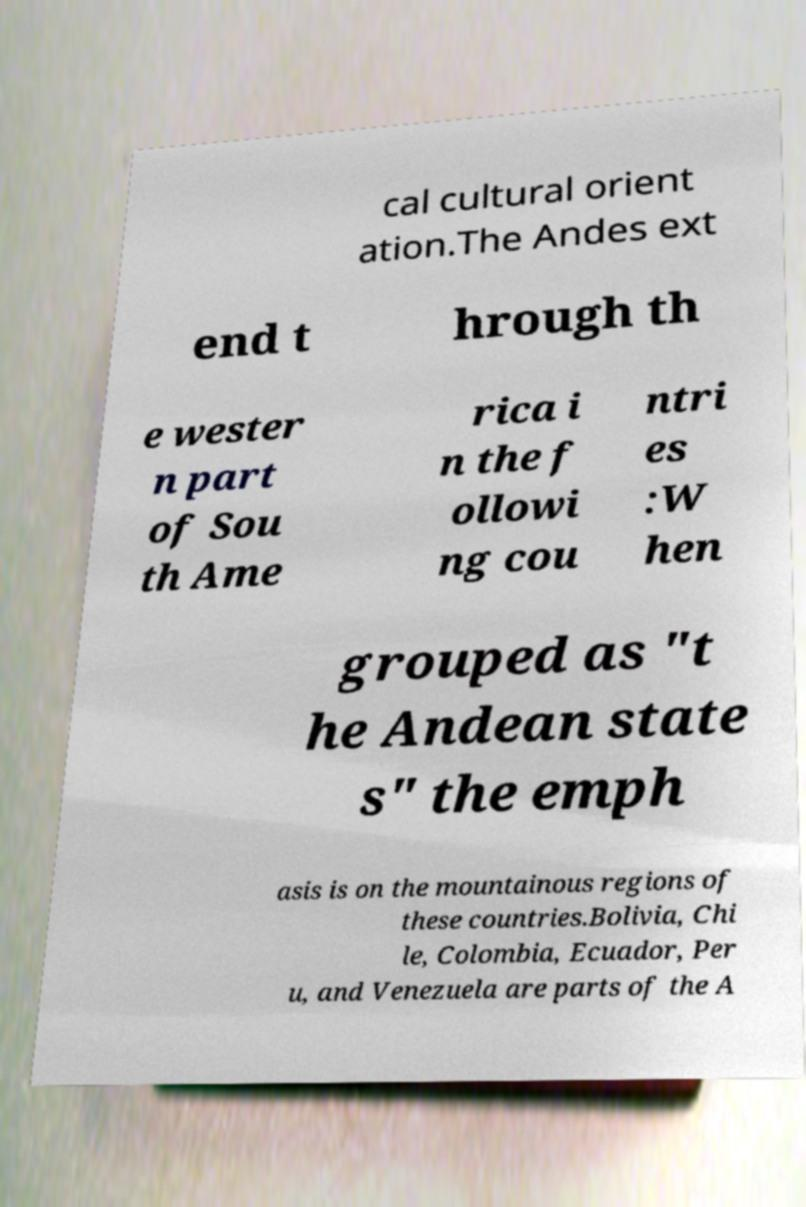For documentation purposes, I need the text within this image transcribed. Could you provide that? cal cultural orient ation.The Andes ext end t hrough th e wester n part of Sou th Ame rica i n the f ollowi ng cou ntri es :W hen grouped as "t he Andean state s" the emph asis is on the mountainous regions of these countries.Bolivia, Chi le, Colombia, Ecuador, Per u, and Venezuela are parts of the A 